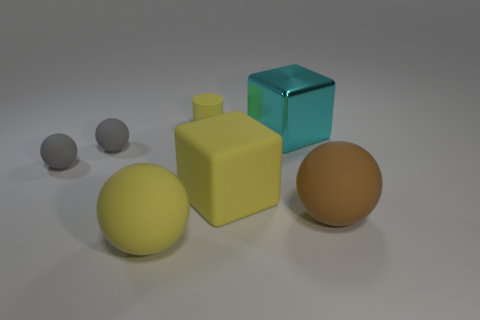Is there any other thing that is the same material as the large cyan cube?
Your answer should be compact. No. Are there any large brown balls right of the big yellow cube?
Offer a very short reply. Yes. Do the yellow sphere left of the yellow rubber block and the large cube to the right of the matte cube have the same material?
Make the answer very short. No. Is the number of large yellow matte balls that are left of the yellow block less than the number of red rubber objects?
Ensure brevity in your answer.  No. What color is the large sphere that is to the right of the matte cylinder?
Keep it short and to the point. Brown. The large cyan thing right of the big yellow thing that is in front of the big yellow rubber cube is made of what material?
Offer a very short reply. Metal. Are there any purple cylinders of the same size as the yellow sphere?
Keep it short and to the point. No. How many objects are balls behind the big brown matte object or large yellow things that are on the left side of the small rubber cylinder?
Your response must be concise. 3. There is a brown sphere to the right of the cyan block; is it the same size as the metallic thing to the right of the rubber cube?
Ensure brevity in your answer.  Yes. There is a big sphere to the right of the tiny yellow matte cylinder; is there a sphere in front of it?
Provide a short and direct response. Yes. 